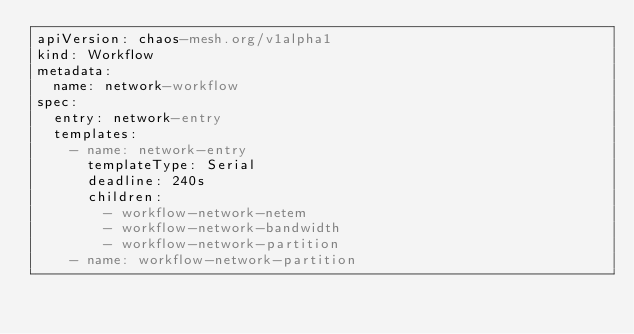<code> <loc_0><loc_0><loc_500><loc_500><_YAML_>apiVersion: chaos-mesh.org/v1alpha1
kind: Workflow
metadata:
  name: network-workflow
spec:
  entry: network-entry
  templates:
    - name: network-entry
      templateType: Serial
      deadline: 240s
      children:
        - workflow-network-netem
        - workflow-network-bandwidth
        - workflow-network-partition
    - name: workflow-network-partition</code> 